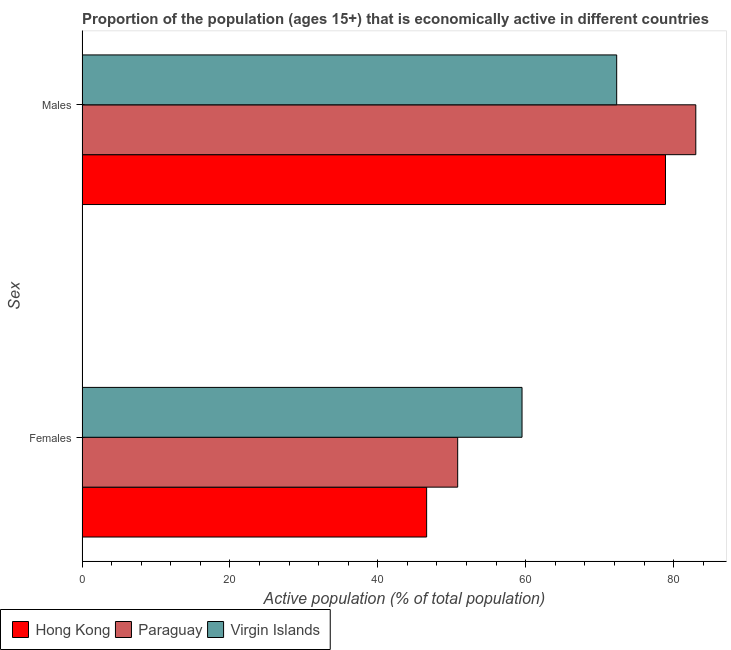How many groups of bars are there?
Your answer should be very brief. 2. How many bars are there on the 1st tick from the top?
Ensure brevity in your answer.  3. How many bars are there on the 1st tick from the bottom?
Make the answer very short. 3. What is the label of the 2nd group of bars from the top?
Keep it short and to the point. Females. What is the percentage of economically active male population in Hong Kong?
Your answer should be compact. 78.9. Across all countries, what is the maximum percentage of economically active male population?
Your response must be concise. 83. Across all countries, what is the minimum percentage of economically active female population?
Your answer should be compact. 46.6. In which country was the percentage of economically active male population maximum?
Keep it short and to the point. Paraguay. In which country was the percentage of economically active male population minimum?
Your response must be concise. Virgin Islands. What is the total percentage of economically active female population in the graph?
Offer a very short reply. 156.9. What is the difference between the percentage of economically active female population in Paraguay and that in Hong Kong?
Offer a terse response. 4.2. What is the difference between the percentage of economically active male population in Virgin Islands and the percentage of economically active female population in Paraguay?
Make the answer very short. 21.5. What is the average percentage of economically active female population per country?
Your answer should be very brief. 52.3. What is the difference between the percentage of economically active female population and percentage of economically active male population in Hong Kong?
Make the answer very short. -32.3. In how many countries, is the percentage of economically active male population greater than 76 %?
Your answer should be very brief. 2. What is the ratio of the percentage of economically active female population in Paraguay to that in Virgin Islands?
Give a very brief answer. 0.85. Is the percentage of economically active female population in Paraguay less than that in Virgin Islands?
Your answer should be compact. Yes. What does the 3rd bar from the top in Females represents?
Offer a very short reply. Hong Kong. What does the 2nd bar from the bottom in Females represents?
Ensure brevity in your answer.  Paraguay. What is the difference between two consecutive major ticks on the X-axis?
Your answer should be very brief. 20. Are the values on the major ticks of X-axis written in scientific E-notation?
Provide a short and direct response. No. Does the graph contain any zero values?
Your answer should be very brief. No. Where does the legend appear in the graph?
Your answer should be compact. Bottom left. How are the legend labels stacked?
Give a very brief answer. Horizontal. What is the title of the graph?
Make the answer very short. Proportion of the population (ages 15+) that is economically active in different countries. Does "Brazil" appear as one of the legend labels in the graph?
Your answer should be very brief. No. What is the label or title of the X-axis?
Ensure brevity in your answer.  Active population (% of total population). What is the label or title of the Y-axis?
Offer a terse response. Sex. What is the Active population (% of total population) in Hong Kong in Females?
Provide a succinct answer. 46.6. What is the Active population (% of total population) in Paraguay in Females?
Offer a very short reply. 50.8. What is the Active population (% of total population) in Virgin Islands in Females?
Give a very brief answer. 59.5. What is the Active population (% of total population) in Hong Kong in Males?
Offer a very short reply. 78.9. What is the Active population (% of total population) in Paraguay in Males?
Make the answer very short. 83. What is the Active population (% of total population) of Virgin Islands in Males?
Ensure brevity in your answer.  72.3. Across all Sex, what is the maximum Active population (% of total population) of Hong Kong?
Provide a short and direct response. 78.9. Across all Sex, what is the maximum Active population (% of total population) of Paraguay?
Keep it short and to the point. 83. Across all Sex, what is the maximum Active population (% of total population) in Virgin Islands?
Offer a terse response. 72.3. Across all Sex, what is the minimum Active population (% of total population) in Hong Kong?
Give a very brief answer. 46.6. Across all Sex, what is the minimum Active population (% of total population) in Paraguay?
Provide a short and direct response. 50.8. Across all Sex, what is the minimum Active population (% of total population) of Virgin Islands?
Provide a succinct answer. 59.5. What is the total Active population (% of total population) of Hong Kong in the graph?
Ensure brevity in your answer.  125.5. What is the total Active population (% of total population) of Paraguay in the graph?
Provide a succinct answer. 133.8. What is the total Active population (% of total population) in Virgin Islands in the graph?
Provide a succinct answer. 131.8. What is the difference between the Active population (% of total population) in Hong Kong in Females and that in Males?
Keep it short and to the point. -32.3. What is the difference between the Active population (% of total population) of Paraguay in Females and that in Males?
Provide a short and direct response. -32.2. What is the difference between the Active population (% of total population) in Virgin Islands in Females and that in Males?
Give a very brief answer. -12.8. What is the difference between the Active population (% of total population) in Hong Kong in Females and the Active population (% of total population) in Paraguay in Males?
Offer a terse response. -36.4. What is the difference between the Active population (% of total population) in Hong Kong in Females and the Active population (% of total population) in Virgin Islands in Males?
Your response must be concise. -25.7. What is the difference between the Active population (% of total population) of Paraguay in Females and the Active population (% of total population) of Virgin Islands in Males?
Your response must be concise. -21.5. What is the average Active population (% of total population) in Hong Kong per Sex?
Keep it short and to the point. 62.75. What is the average Active population (% of total population) in Paraguay per Sex?
Provide a short and direct response. 66.9. What is the average Active population (% of total population) of Virgin Islands per Sex?
Your answer should be very brief. 65.9. What is the difference between the Active population (% of total population) in Hong Kong and Active population (% of total population) in Paraguay in Females?
Ensure brevity in your answer.  -4.2. What is the difference between the Active population (% of total population) of Hong Kong and Active population (% of total population) of Paraguay in Males?
Make the answer very short. -4.1. What is the difference between the Active population (% of total population) in Hong Kong and Active population (% of total population) in Virgin Islands in Males?
Make the answer very short. 6.6. What is the ratio of the Active population (% of total population) in Hong Kong in Females to that in Males?
Make the answer very short. 0.59. What is the ratio of the Active population (% of total population) in Paraguay in Females to that in Males?
Offer a very short reply. 0.61. What is the ratio of the Active population (% of total population) in Virgin Islands in Females to that in Males?
Ensure brevity in your answer.  0.82. What is the difference between the highest and the second highest Active population (% of total population) of Hong Kong?
Ensure brevity in your answer.  32.3. What is the difference between the highest and the second highest Active population (% of total population) of Paraguay?
Provide a short and direct response. 32.2. What is the difference between the highest and the second highest Active population (% of total population) of Virgin Islands?
Offer a very short reply. 12.8. What is the difference between the highest and the lowest Active population (% of total population) of Hong Kong?
Your answer should be compact. 32.3. What is the difference between the highest and the lowest Active population (% of total population) in Paraguay?
Your response must be concise. 32.2. 